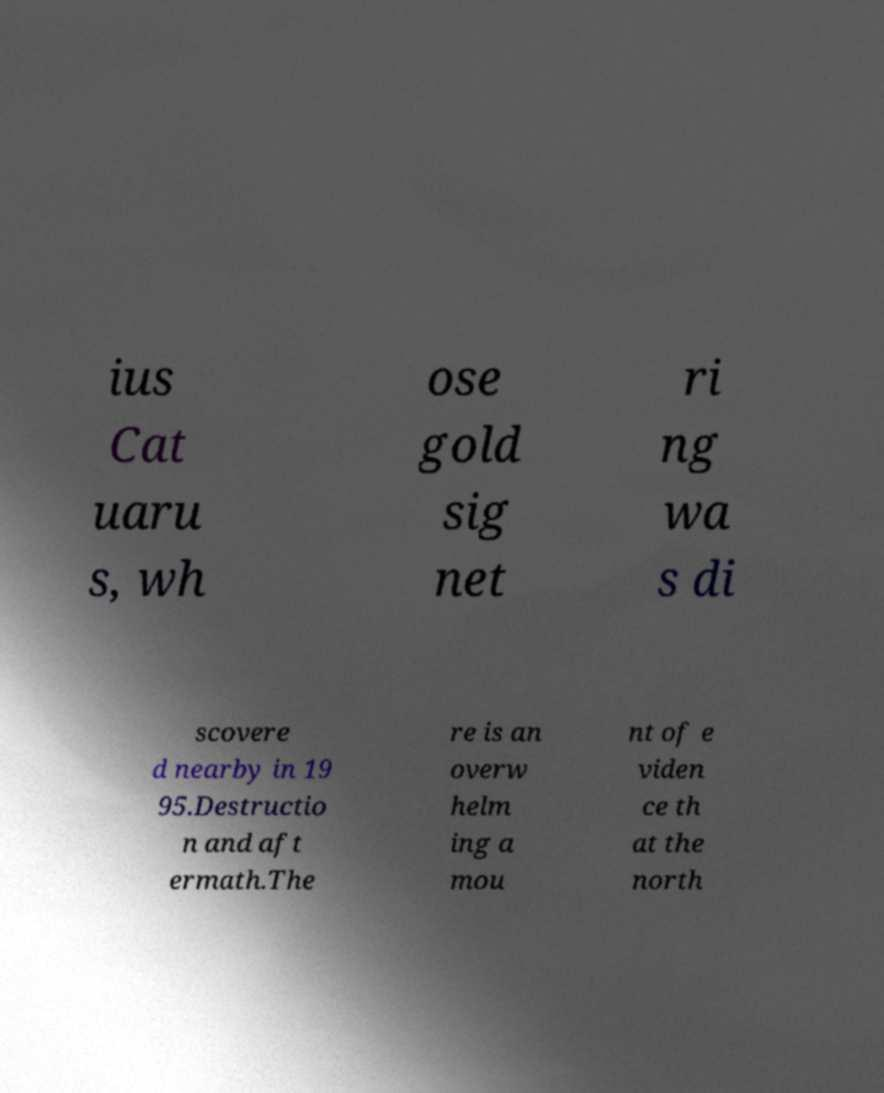Please identify and transcribe the text found in this image. ius Cat uaru s, wh ose gold sig net ri ng wa s di scovere d nearby in 19 95.Destructio n and aft ermath.The re is an overw helm ing a mou nt of e viden ce th at the north 